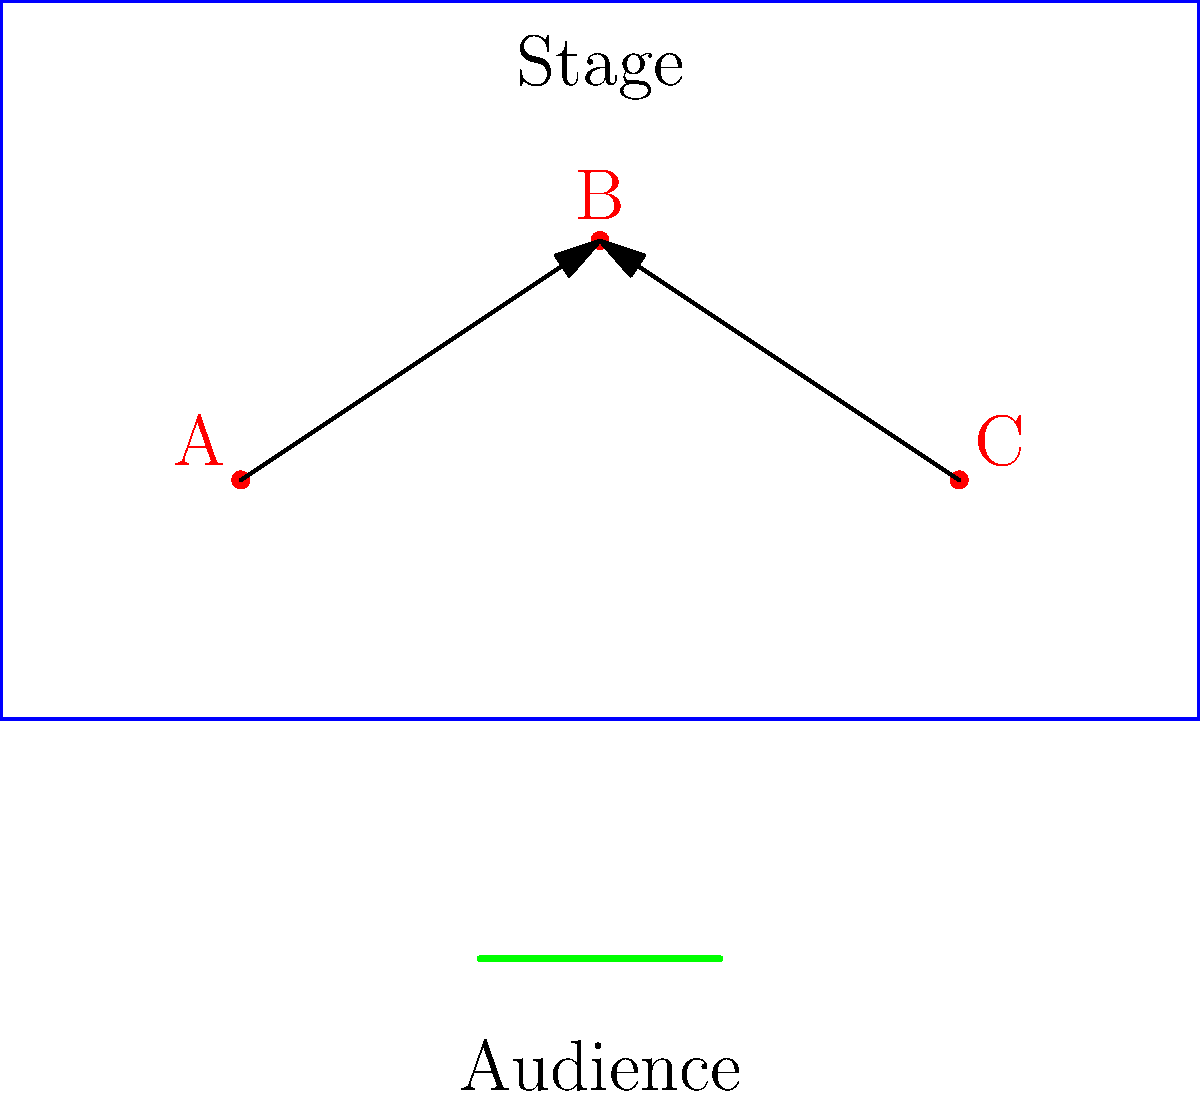In the diagram above, three vocalists (A, B, and C) are positioned on a stage. For optimal acoustics and harmonization, vocalist B should be placed at a specific distance from both A and C. If the stage is 10 meters wide and 6 meters deep, and the current positions of A and C are fixed, what is the ideal distance (in meters) that B should be from both A and C? To solve this problem, we need to follow these steps:

1. Identify the coordinates of each vocalist:
   A: (2, 2)
   B: (5, 4)
   C: (8, 2)

2. Calculate the distance between A and C:
   $d_{AC} = \sqrt{(x_C - x_A)^2 + (y_C - y_A)^2}$
   $d_{AC} = \sqrt{(8 - 2)^2 + (2 - 2)^2} = \sqrt{36} = 6$ meters

3. For optimal acoustics and harmonization, B should form an equilateral triangle with A and C. In an equilateral triangle, all sides are equal.

4. The ideal distance from B to both A and C should be equal to the distance between A and C:
   $d_{AB} = d_{BC} = d_{AC} = 6$ meters

5. To verify, we can calculate the actual distances:
   $d_{AB} = \sqrt{(5 - 2)^2 + (4 - 2)^2} = \sqrt{13} \approx 3.61$ meters
   $d_{BC} = \sqrt{(8 - 5)^2 + (2 - 4)^2} = \sqrt{13} \approx 3.61$ meters

6. The current position of B is not optimal. B should be moved to form an equilateral triangle with A and C, maintaining a distance of 6 meters from both.
Answer: 6 meters 